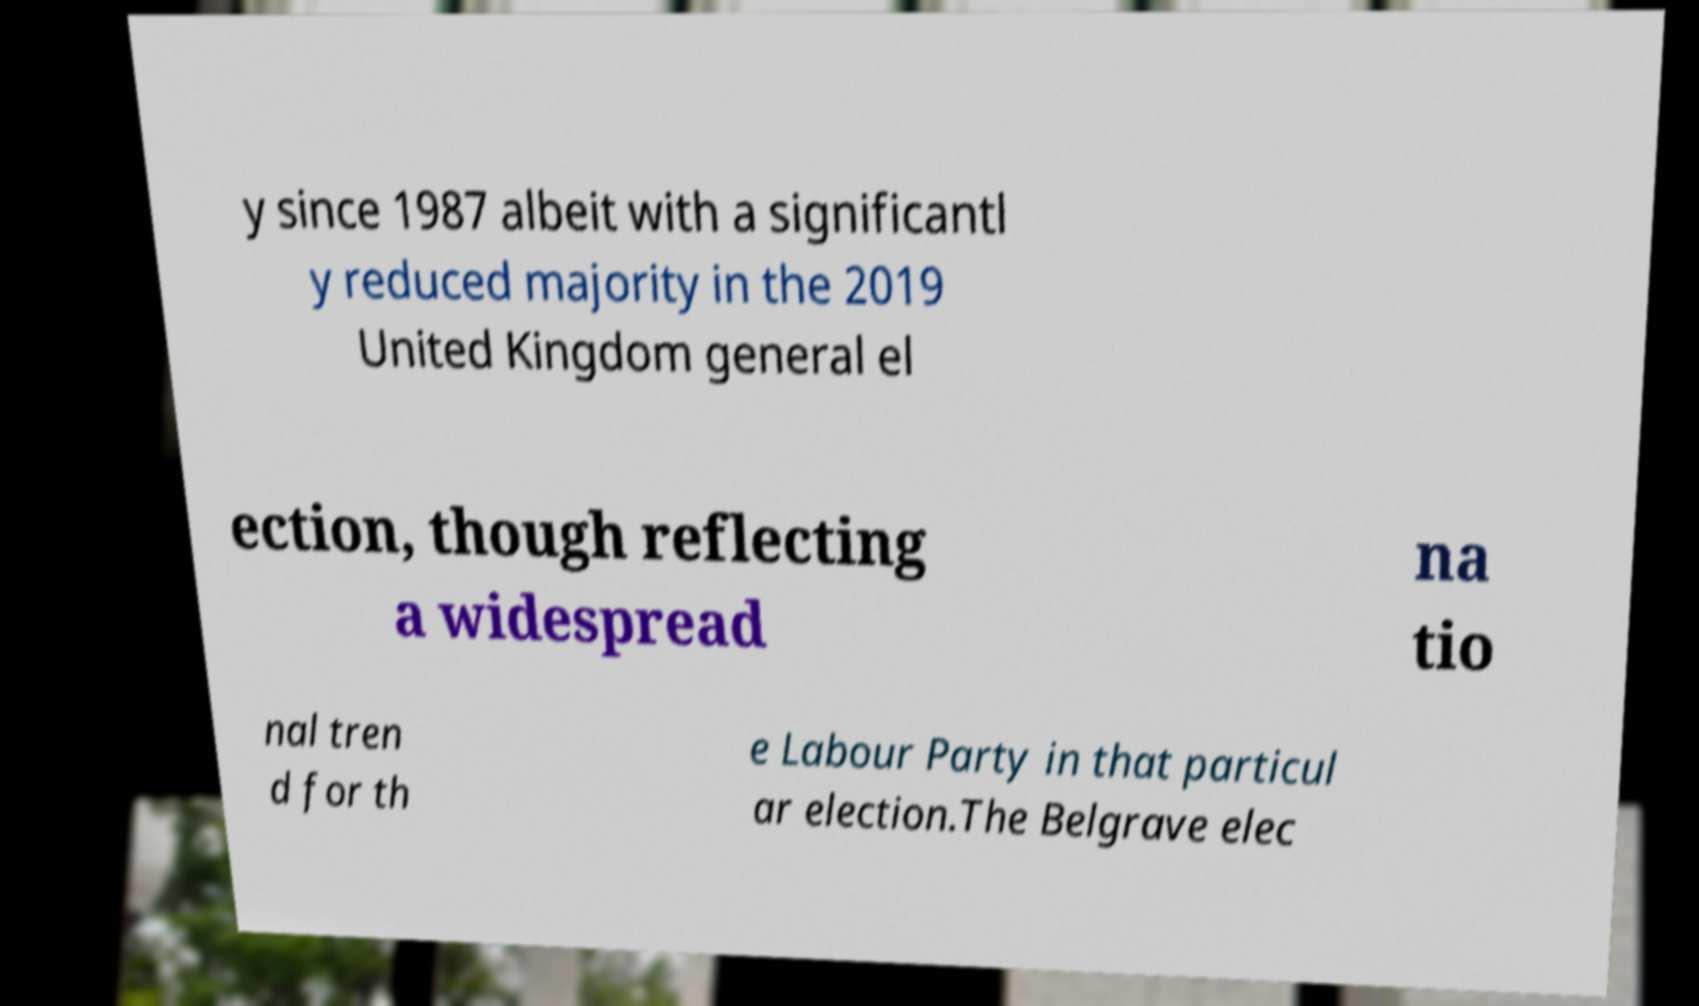There's text embedded in this image that I need extracted. Can you transcribe it verbatim? y since 1987 albeit with a significantl y reduced majority in the 2019 United Kingdom general el ection, though reflecting a widespread na tio nal tren d for th e Labour Party in that particul ar election.The Belgrave elec 